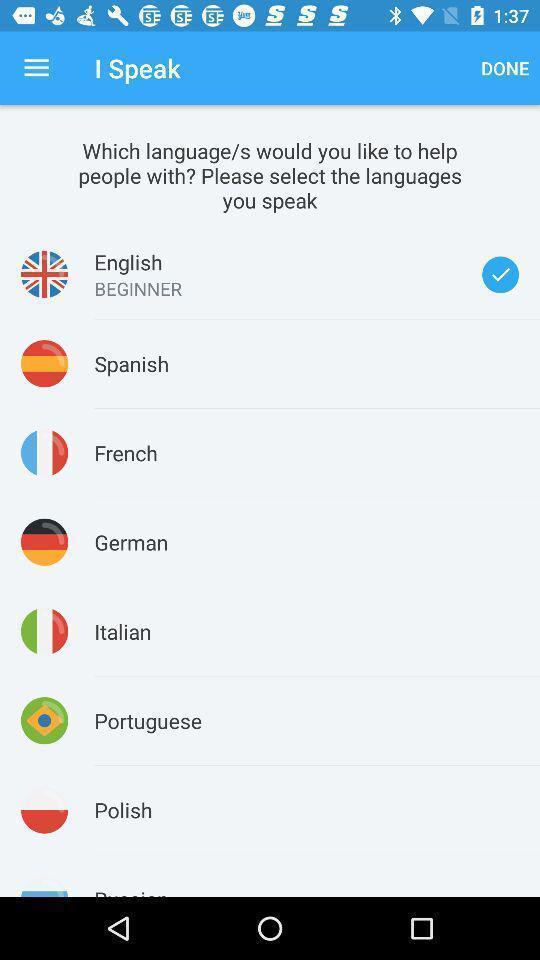Provide a description of this screenshot. Page displaying to select language among them. 